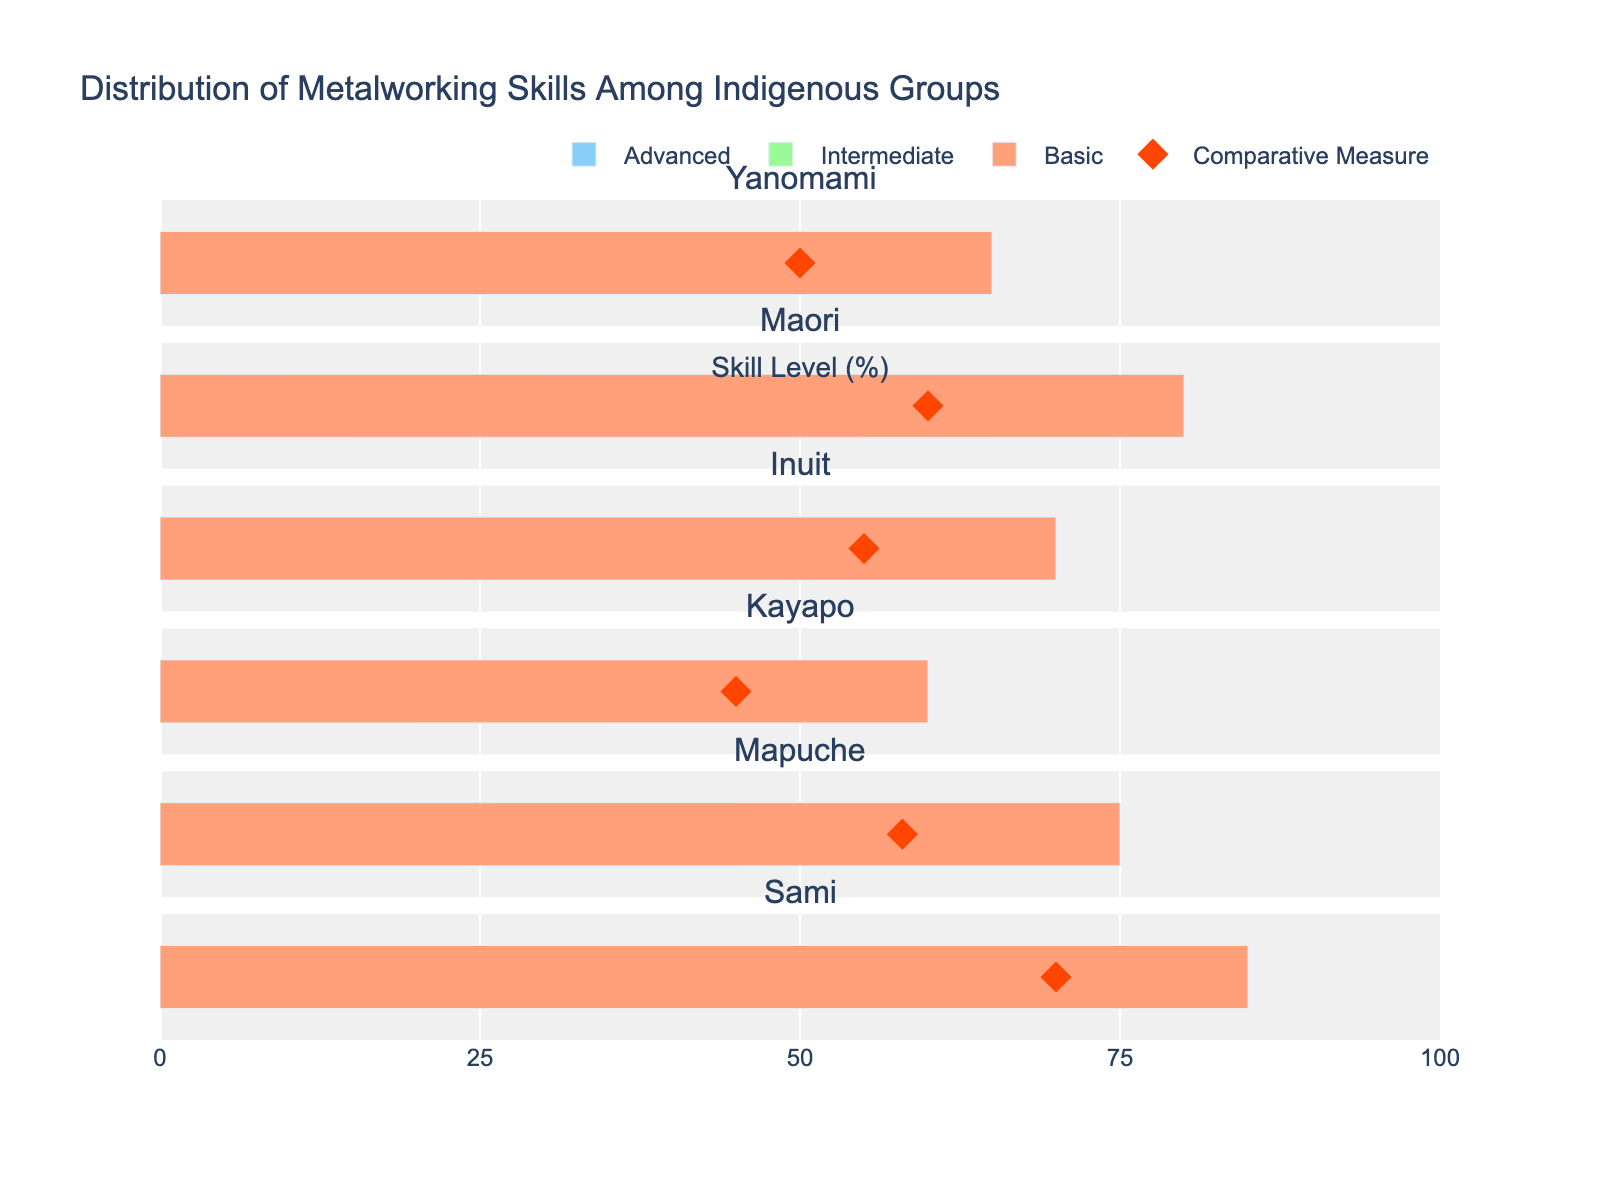Which tribe has the highest value for Basic skills? By looking at the bars colored for Basic skills, the Sami tribe has the highest value at 85%, which is higher than the others.
Answer: Sami What's the difference in Advanced skills between the Maori and the Yanomami tribes? The Maori tribe has 30% in Advanced skills, and the Yanomami tribe has 15%. The difference is 30% - 15% = 15%.
Answer: 15% Which tribe's Comparative Measure is the highest? By inspecting the diamond markers representing the Comparative Measure, the Sami tribe has the highest value at 70%.
Answer: Sami What is the combined percentage of Basic and Intermediate skills for the Mapuche tribe? The Basic skills of the Mapuche tribe are 75%, and the Intermediate skills are 45%. Adding them yields 75% + 45% = 120%.
Answer: 120% Which tribe shows the smallest difference between Basic and Advanced skills? The Kayapo tribe has 60% (Basic) and 10% (Advanced). The difference is 60% - 10% = 50%, which is the smallest compared to other tribes.
Answer: Kayapo How much higher is the Comparative Measure for the Maori tribe compared to its Basic skills? The Comparative Measure for the Maori tribe is 60%, while the Basic skills are 80%. The difference is 80% - 60% = 20%.
Answer: 20% Among the tribes, which one has the lowest Intermediate skill level? The Kayapo tribe has the lowest Intermediate skill level at 35%, compared to other tribes.
Answer: Kayapo If the Intermediate and Advanced skills for the Inuit tribe were combined, what would be their total percentage? The Intermediate skills for the Inuit tribe are 50%, and the Advanced skills are 20%. Adding them together gives 50% + 20% = 70%.
Answer: 70% Compare the Yanomami and Mapuche tribes: which has a higher Basic skill level and by how much? The Yanomami tribe has a Basic skill level of 65%, and the Mapuche tribe has 75%. The difference is 75% - 65% = 10%, making the Mapuche's level higher.
Answer: 10% How does the Comparative Measure for the Kayapo tribe compare with its total of Basic, Intermediate, and Advanced skills? The Comparative Measure for the Kayapo tribe is 45%, and the total of Basic, Intermediate, and Advanced skills is 60% + 35% + 10% = 105%.
Answer: The Comparative Measure is lower by 60% 